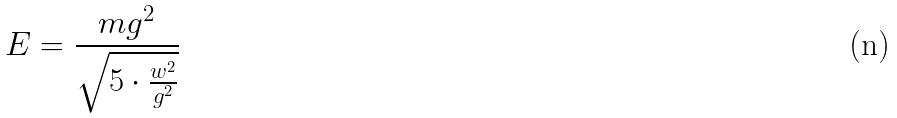<formula> <loc_0><loc_0><loc_500><loc_500>E = \frac { m g ^ { 2 } } { \sqrt { 5 \cdot \frac { w ^ { 2 } } { g ^ { 2 } } } }</formula> 